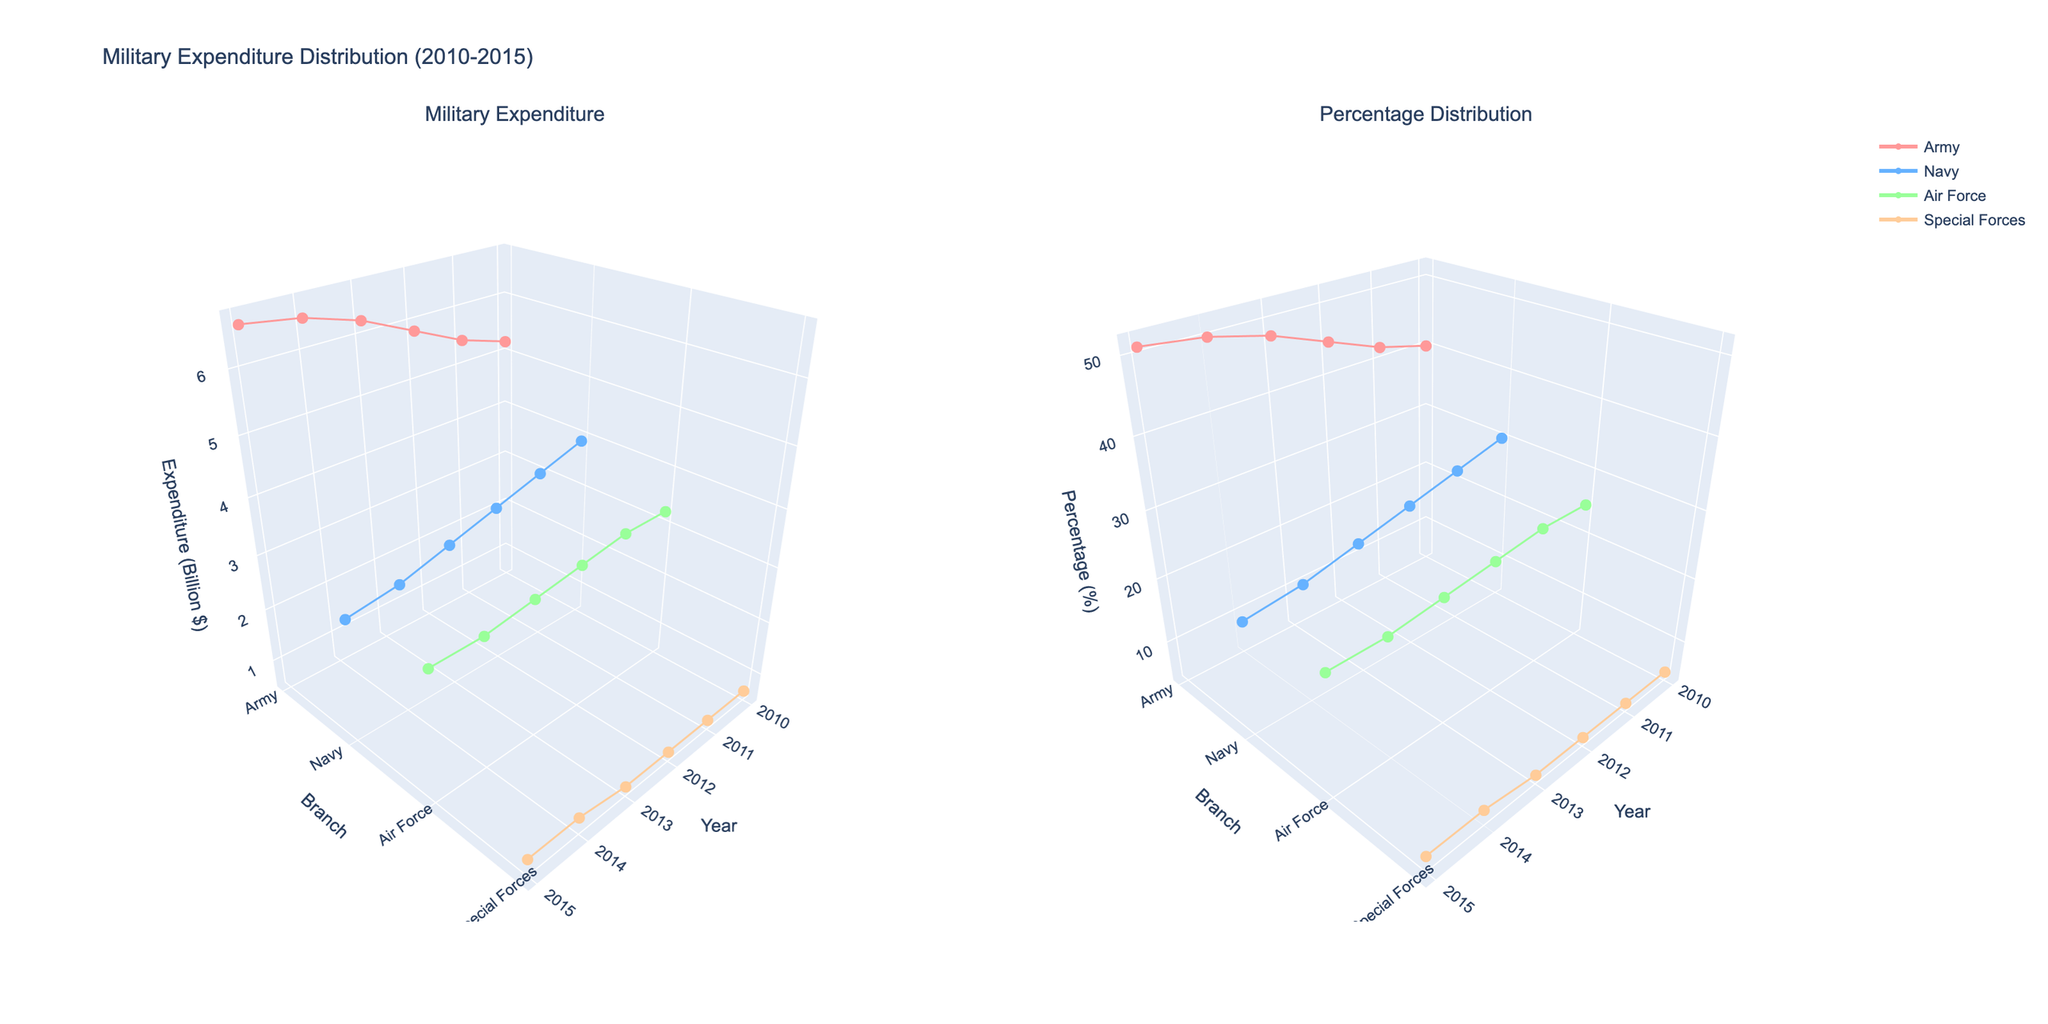What is the title of the figure? The title of the figure is located at the very top of the plot. It summarizes the main focus of the two subplots.
Answer: Military Expenditure Distribution (2010-2015) How many branches of the armed forces are visualized in the plots? Each subplot contains lines representing expenditure data for different armed force branches. Counting these lines reveals the number of branches.
Answer: 4 Which branch has the highest expenditure in 2015? By inspecting the expenditure subplot, identify the branch with the highest vertical coordinate (z-axis) for the year 2015.
Answer: Army What is the total expenditure in 2010? To find the total expenditure for 2010, sum the z-values (expenditure) for all branches in the year 2010.
Answer: 13.0 Billion $ Compare the expenditure trend for the Army from 2010 to 2015. Is it increasing or decreasing? Look at the expenditure lines in the plot from 2010 to 2015 for the Army. An upward trend indicates increasing expenditure, while a downward trend indicates decreasing expenditure.
Answer: Increasing Which branch shows the most significant drop in percentage from 2010 to 2015? Check the percentage plot and observe which branch's z-values have decreased the most from 2010 to 2015.
Answer: Navy In which year is the percentage of military expenditure for the Special Forces the highest? Look at the percentage plot for the Special Forces and identify the year with the highest z-value.
Answer: 2014 and 2015 What is the percentage of Navy expenditure in 2013? Refer to the percentage plot and identify the z-value for the Navy in 2013.
Answer: 24% Compare the expenditure of the Air Force to that of the Navy in 2012. Which one is higher? Look at the expenditure subplot and compare the z-values of the Air Force and the Navy in the year 2012.
Answer: Air Force How does the expenditure change for the Special Forces from 2010 to 2015? Examine the expenditure subplot and compare the z-values for the Special Forces across the years 2010 to 2015.
Answer: Relatively Stable 